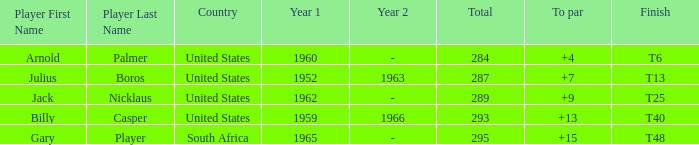What was Gary Player's highest total when his To par was over 15? None. 